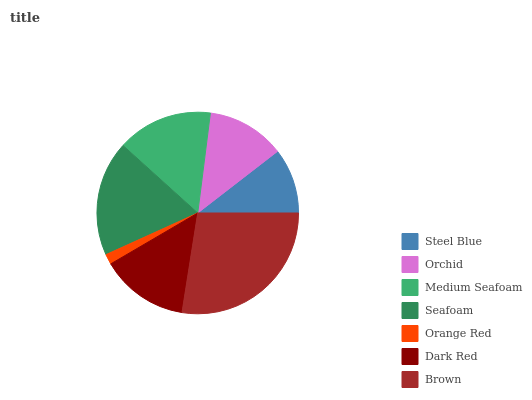Is Orange Red the minimum?
Answer yes or no. Yes. Is Brown the maximum?
Answer yes or no. Yes. Is Orchid the minimum?
Answer yes or no. No. Is Orchid the maximum?
Answer yes or no. No. Is Orchid greater than Steel Blue?
Answer yes or no. Yes. Is Steel Blue less than Orchid?
Answer yes or no. Yes. Is Steel Blue greater than Orchid?
Answer yes or no. No. Is Orchid less than Steel Blue?
Answer yes or no. No. Is Dark Red the high median?
Answer yes or no. Yes. Is Dark Red the low median?
Answer yes or no. Yes. Is Steel Blue the high median?
Answer yes or no. No. Is Steel Blue the low median?
Answer yes or no. No. 